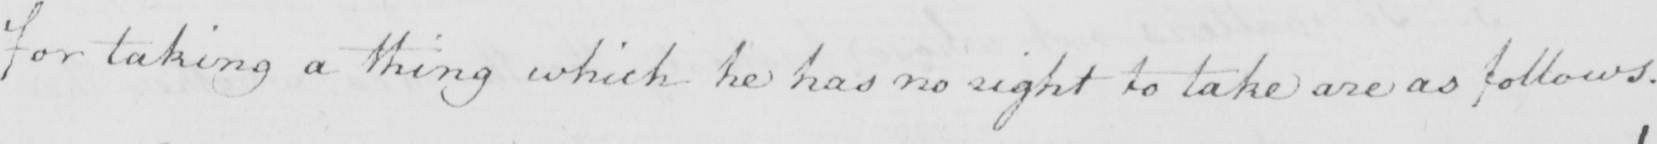Can you read and transcribe this handwriting? for taking a thing which he has no right to take are as follows . 